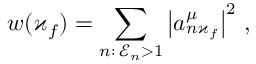Convert formula to latex. <formula><loc_0><loc_0><loc_500><loc_500>w ( \varkappa _ { f } ) = \sum _ { n \colon \, \mathcal { E } _ { n } > 1 } \left | a _ { n \varkappa _ { f } } ^ { \mu } \right | ^ { 2 } \, ,</formula> 